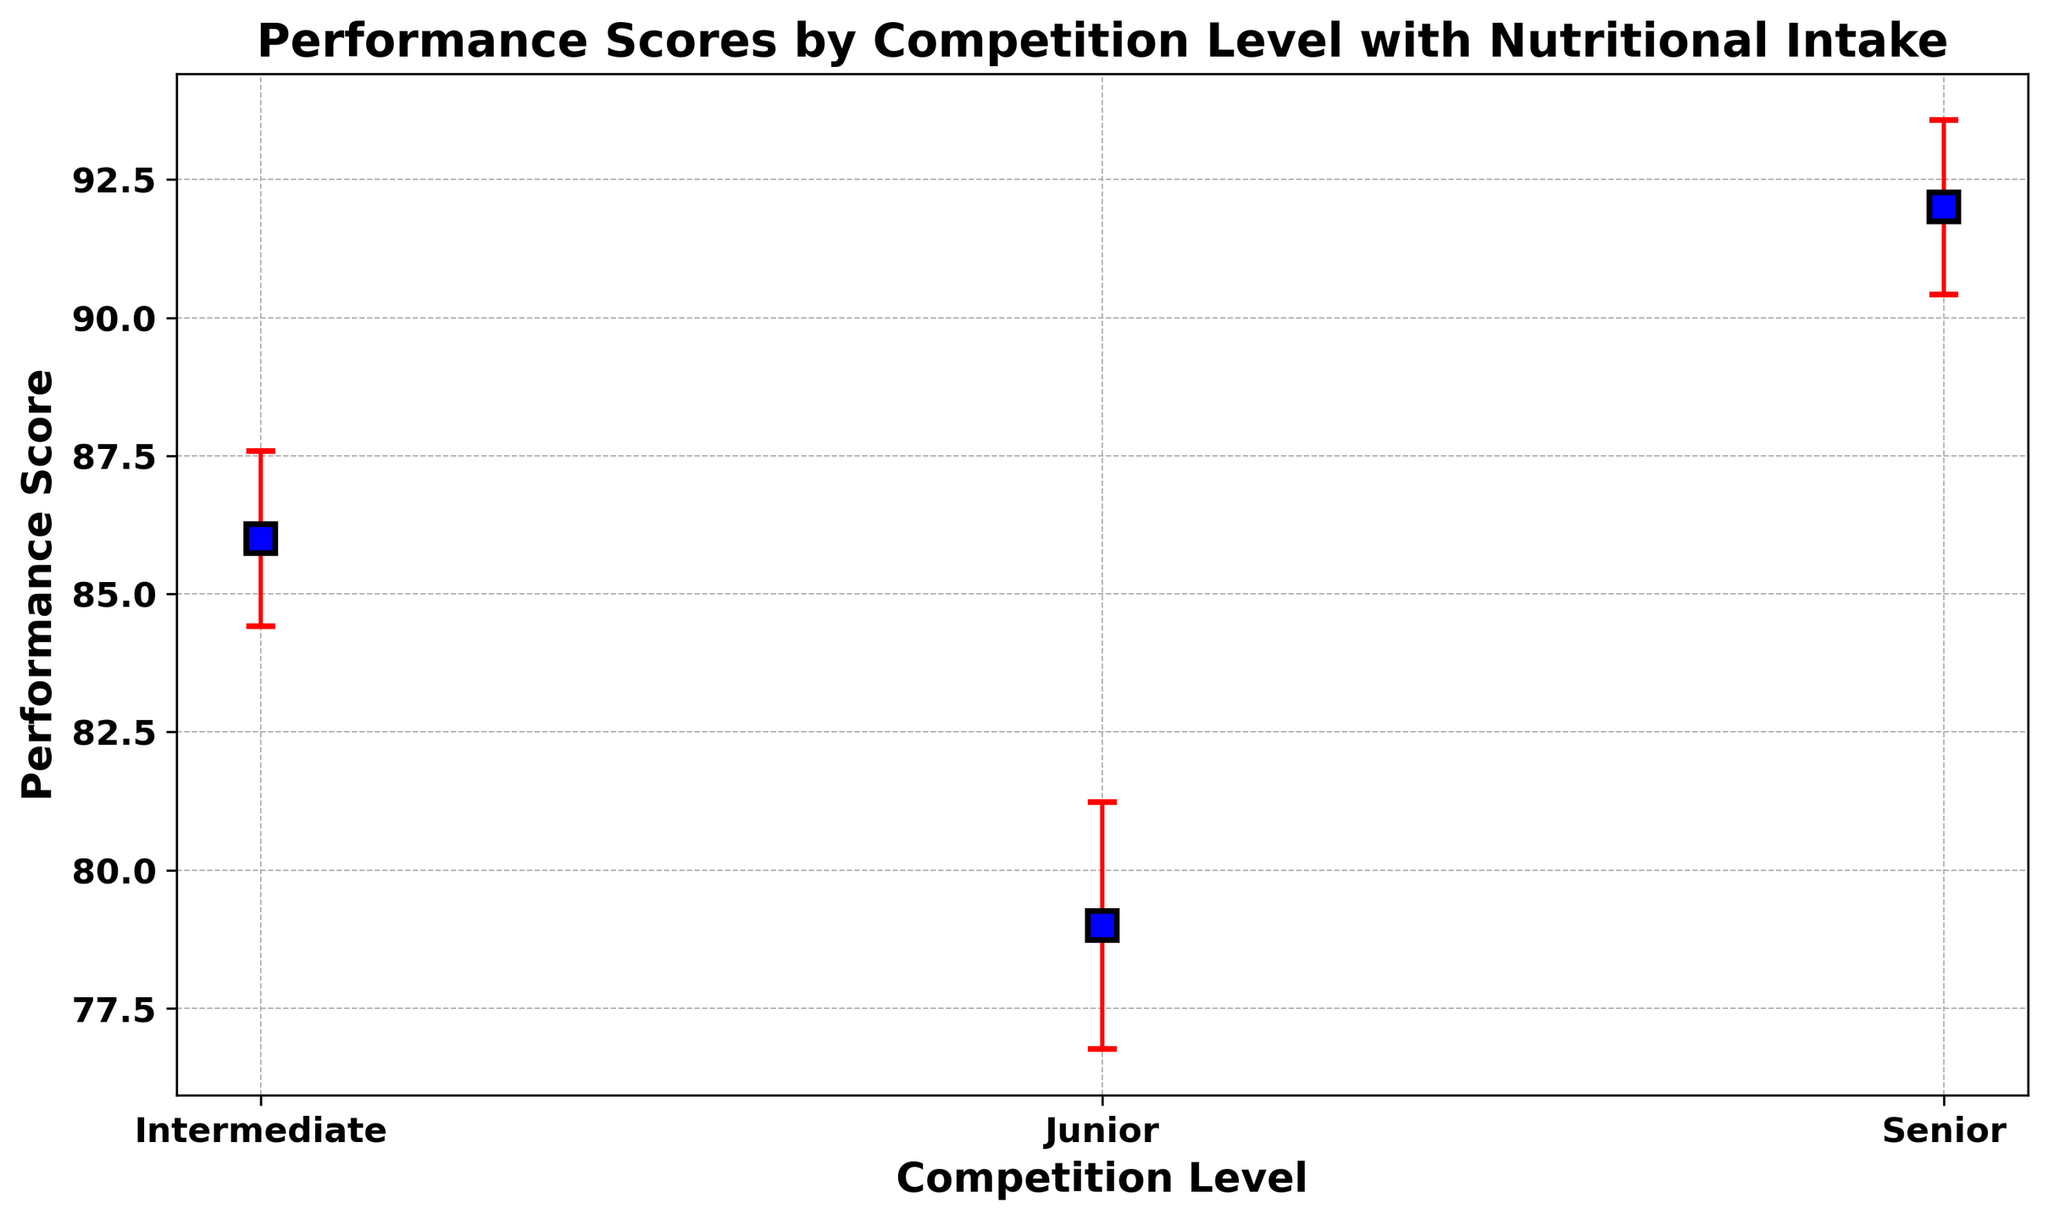How do the performance scores of Senior athletes compare to Junior athletes, on average? Looking at the figure, the mean performance score for Senior athletes is higher than the mean performance score for Junior athletes, as the Senior points are plotted higher on the y-axis.
Answer: Senior athletes have higher performance scores What is the level of variation in performance scores for Intermediate athletes compared to Juniors? The error bars for Intermediate athletes are shorter than those for Junior athletes, indicating less variation in performance scores.
Answer: Intermediate athletes have less variation What is the approximate mean performance score for Senior athletes? The plot shows the error bars centered on a mean value on the y-axis for the Senior group, approximately in the range of 92-94.
Answer: Approximately 92-94 Between which competition levels do performance scores show the highest variability? The length of the error bars indicates variability. The longest error bars are seen for the Junior athletes, indicating the highest variability in performance scores.
Answer: Junior athletes show the highest variability How does the average performance score change as competition level increases from Junior to Intermediate to Senior? The mean performance score increases with each competition level, as indicated by the ascending trend of the plotted means from left to right on the x-axis.
Answer: The average performance score increases What is the mean performance score for Junior athletes based on the plotted data? The figure shows that the mean performance score for Junior athletes is centered around 79-80 on the y-axis.
Answer: Approximately 79-80 Compare the trend in performance scores and their variation between Intermediate and Senior athletes. The mean performance score for Seniors is higher than for Intermediate athletes. The error bars for Seniors are relatively longer, indicating slightly more variation in their performance scores.
Answer: Seniors have higher scores and slightly more variation Do the error bars overlap between any two competition levels, indicating similar performance scores? No significant overlap is visible between the error bars for Junior, Intermediate, and Senior levels, suggesting distinct performance scores for each level.
Answer: No, they do not overlap 